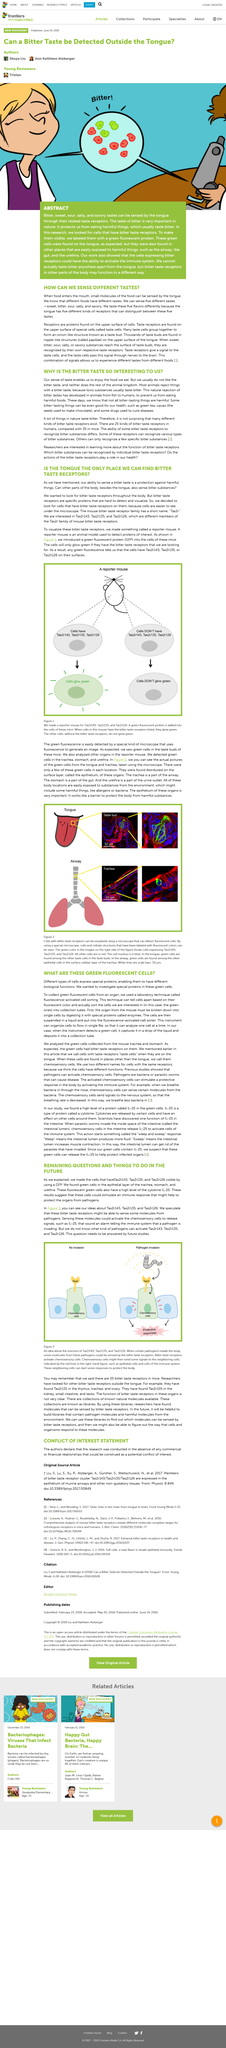Give some essential details in this illustration. As stated in the article, taste is what enables us to enjoy the food we eat. The article states that cacao seeds are used to make chocolate. It is not possible for the bitter taste receptor cells in the urethra to allow an individual to taste bitterness, as these cells do not have the capacity to detect bitterness. Tas2r143 is a type of bitter taste receptor. The role of bitter taste receptors in nature is to prevent us from consuming harmful substances by signaling the presence of toxins and causing aversion to their taste. 